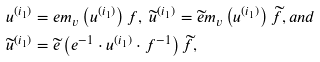<formula> <loc_0><loc_0><loc_500><loc_500>& u ^ { ( i _ { 1 } ) } = e m _ { v } \left ( u ^ { ( i _ { 1 } ) } \right ) f , \ \widetilde { u } ^ { ( i _ { 1 } ) } = \widetilde { e } m _ { v } \left ( u ^ { ( i _ { 1 } ) } \right ) \widetilde { f } , a n d \\ & \widetilde { u } ^ { ( i _ { 1 } ) } = \widetilde { e } \left ( e ^ { - 1 } \cdot u ^ { ( i _ { 1 } ) } \cdot f ^ { - 1 } \right ) \widetilde { f } ,</formula> 